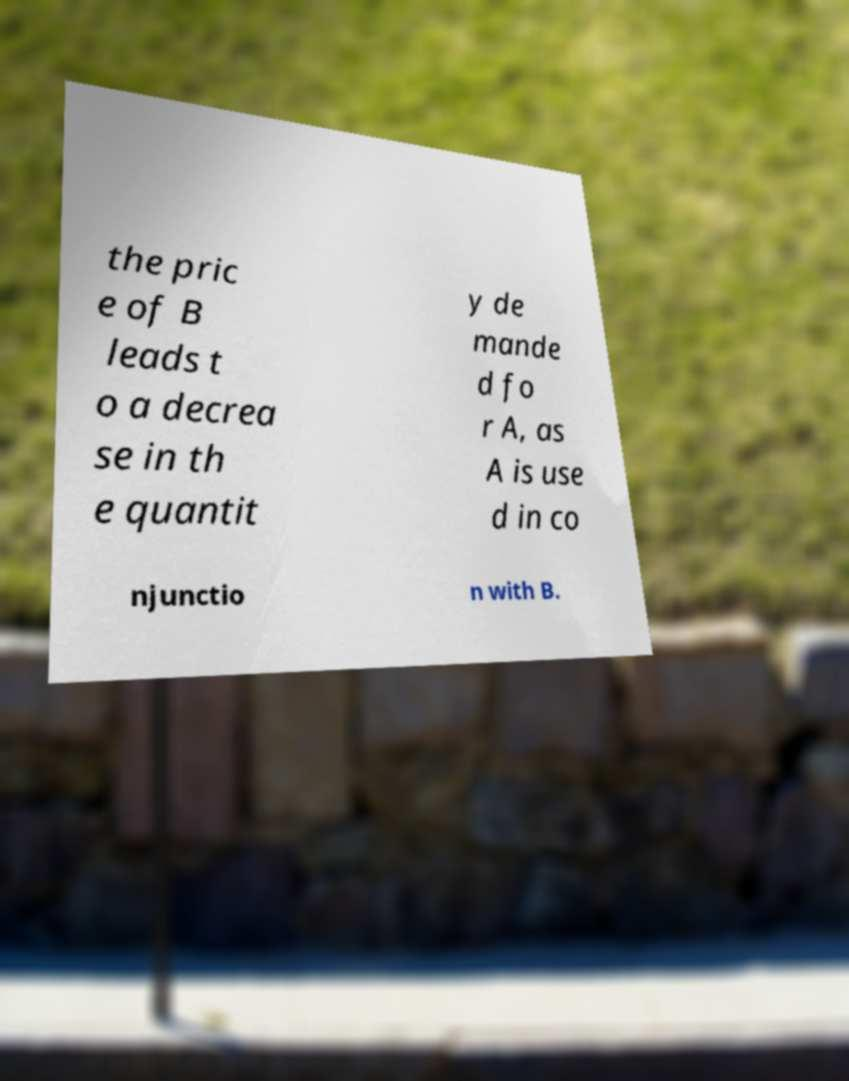I need the written content from this picture converted into text. Can you do that? the pric e of B leads t o a decrea se in th e quantit y de mande d fo r A, as A is use d in co njunctio n with B. 